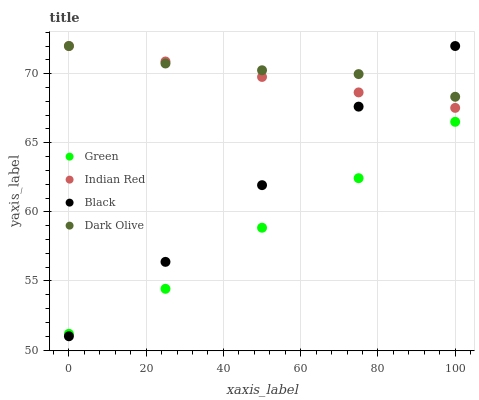Does Green have the minimum area under the curve?
Answer yes or no. Yes. Does Dark Olive have the maximum area under the curve?
Answer yes or no. Yes. Does Dark Olive have the minimum area under the curve?
Answer yes or no. No. Does Green have the maximum area under the curve?
Answer yes or no. No. Is Indian Red the smoothest?
Answer yes or no. Yes. Is Green the roughest?
Answer yes or no. Yes. Is Dark Olive the smoothest?
Answer yes or no. No. Is Dark Olive the roughest?
Answer yes or no. No. Does Black have the lowest value?
Answer yes or no. Yes. Does Green have the lowest value?
Answer yes or no. No. Does Indian Red have the highest value?
Answer yes or no. Yes. Does Green have the highest value?
Answer yes or no. No. Is Green less than Indian Red?
Answer yes or no. Yes. Is Indian Red greater than Green?
Answer yes or no. Yes. Does Black intersect Indian Red?
Answer yes or no. Yes. Is Black less than Indian Red?
Answer yes or no. No. Is Black greater than Indian Red?
Answer yes or no. No. Does Green intersect Indian Red?
Answer yes or no. No. 